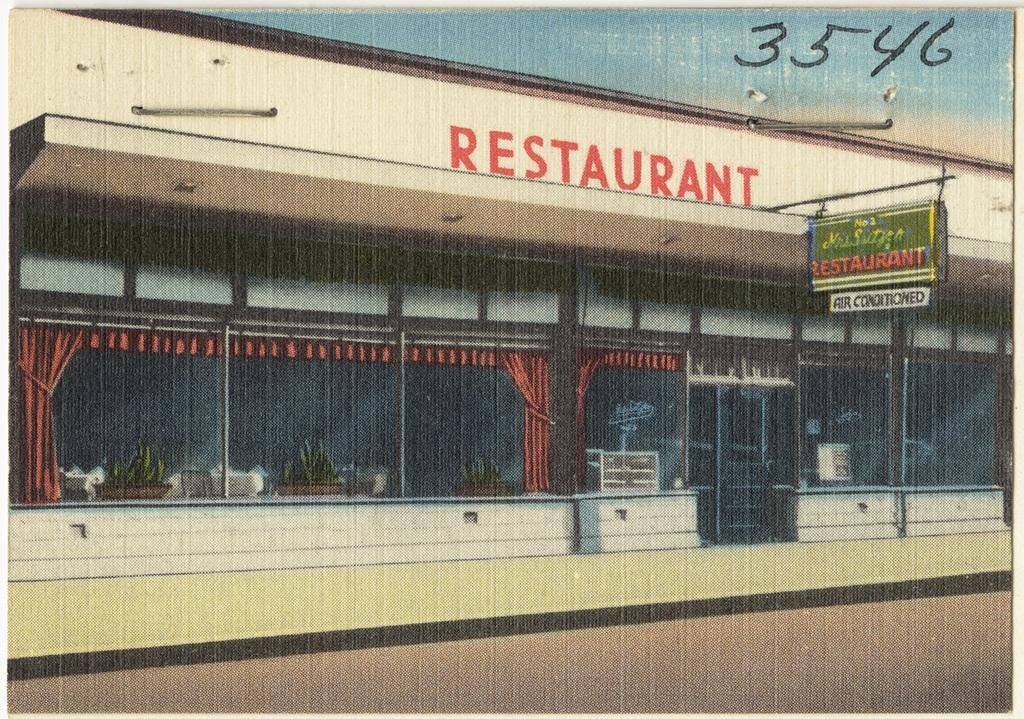Could you give a brief overview of what you see in this image? In this image I can see the photograph of a building which is cream and brown in color. I can see few glass windows through which I can see few plants and few curtains which are red in color. I can see a board and in the background I can see the sky. 